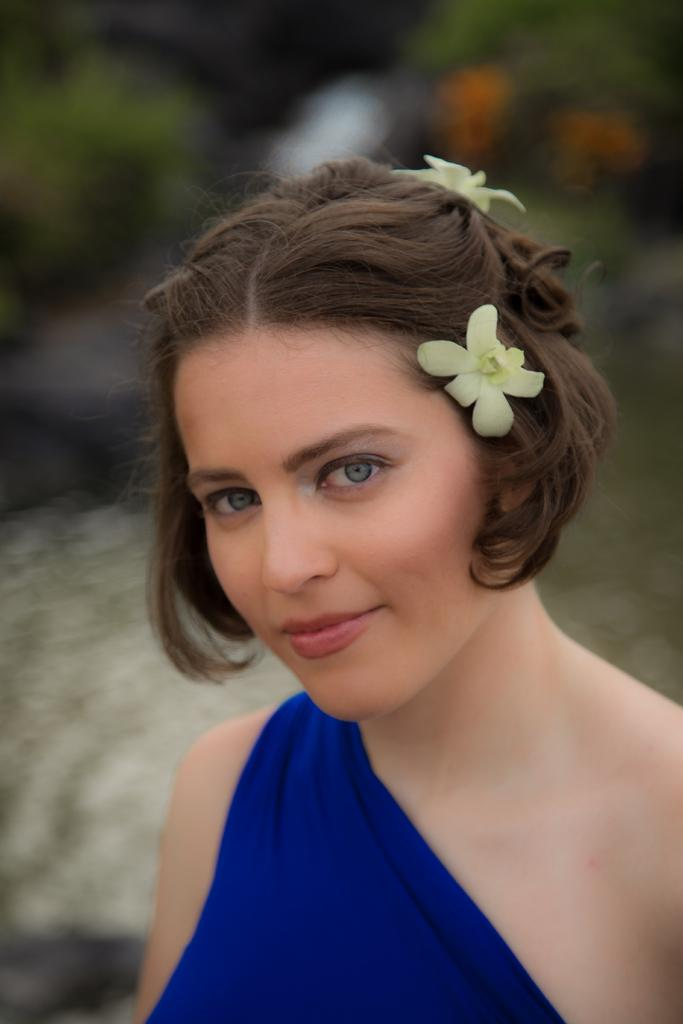Who is the main subject in the image? There is a woman in the image. What is the woman wearing? The woman is wearing a blue dress. What can be seen in the background of the image? There is a plant in the background of the image. How would you describe the background of the image? The background of the image appears blurry. How many stockings is the woman wearing in the image? There is no mention of stockings in the image, so we cannot determine how many the woman is wearing. 